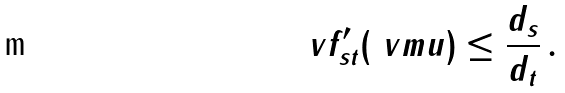<formula> <loc_0><loc_0><loc_500><loc_500>\ v f ^ { \prime } _ { s t } ( \ v m u ) \leq \frac { d _ { s } } { d _ { t } } \, .</formula> 